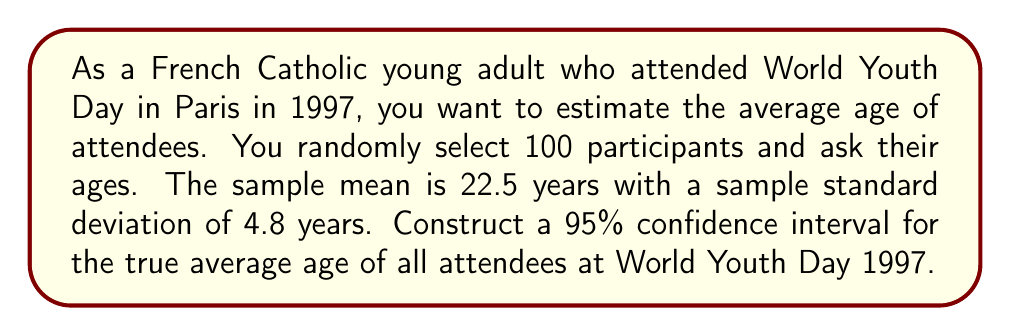What is the answer to this math problem? To construct a 95% confidence interval for the true average age, we'll use the formula:

$$ \text{CI} = \bar{x} \pm t_{\alpha/2} \cdot \frac{s}{\sqrt{n}} $$

Where:
- $\bar{x}$ is the sample mean (22.5 years)
- $s$ is the sample standard deviation (4.8 years)
- $n$ is the sample size (100)
- $t_{\alpha/2}$ is the t-value for a 95% confidence level with $n-1$ degrees of freedom

Steps:
1) Find $t_{\alpha/2}$:
   For a 95% confidence level and 99 degrees of freedom, $t_{\alpha/2} \approx 1.984$ (from t-distribution table)

2) Calculate the margin of error:
   $$ \text{ME} = t_{\alpha/2} \cdot \frac{s}{\sqrt{n}} = 1.984 \cdot \frac{4.8}{\sqrt{100}} = 1.984 \cdot 0.48 = 0.952 $$

3) Construct the confidence interval:
   $$ \text{CI} = 22.5 \pm 0.952 $$
   $$ \text{CI} = (21.548, 23.452) $$

Therefore, we can be 95% confident that the true average age of all attendees at World Youth Day 1997 falls between 21.548 and 23.452 years.
Answer: The 95% confidence interval for the true average age of attendees at World Youth Day 1997 is (21.548, 23.452) years. 